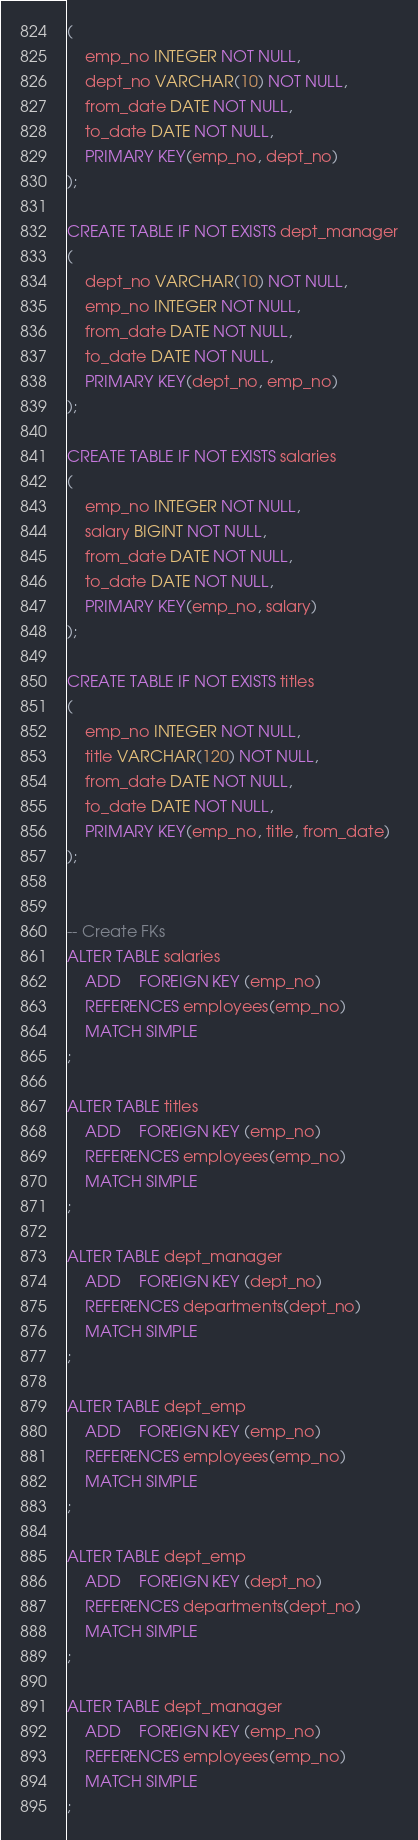Convert code to text. <code><loc_0><loc_0><loc_500><loc_500><_SQL_>(
    emp_no INTEGER NOT NULL,
    dept_no VARCHAR(10) NOT NULL,
    from_date DATE NOT NULL,
    to_date DATE NOT NULL,
    PRIMARY KEY(emp_no, dept_no)
);

CREATE TABLE IF NOT EXISTS dept_manager
(
    dept_no VARCHAR(10) NOT NULL,
    emp_no INTEGER NOT NULL,
    from_date DATE NOT NULL,
    to_date DATE NOT NULL,
    PRIMARY KEY(dept_no, emp_no)
);

CREATE TABLE IF NOT EXISTS salaries
(
    emp_no INTEGER NOT NULL,
    salary BIGINT NOT NULL,
    from_date DATE NOT NULL,
    to_date DATE NOT NULL,
    PRIMARY KEY(emp_no, salary)
);

CREATE TABLE IF NOT EXISTS titles
(
    emp_no INTEGER NOT NULL,
    title VARCHAR(120) NOT NULL,
    from_date DATE NOT NULL,
    to_date DATE NOT NULL,
    PRIMARY KEY(emp_no, title, from_date)
);


-- Create FKs
ALTER TABLE salaries
    ADD    FOREIGN KEY (emp_no)
    REFERENCES employees(emp_no)
    MATCH SIMPLE
;
    
ALTER TABLE titles
    ADD    FOREIGN KEY (emp_no)
    REFERENCES employees(emp_no)
    MATCH SIMPLE
;
    
ALTER TABLE dept_manager
    ADD    FOREIGN KEY (dept_no)
    REFERENCES departments(dept_no)
    MATCH SIMPLE
;
    
ALTER TABLE dept_emp
    ADD    FOREIGN KEY (emp_no)
    REFERENCES employees(emp_no)
    MATCH SIMPLE
;
    
ALTER TABLE dept_emp
    ADD    FOREIGN KEY (dept_no)
    REFERENCES departments(dept_no)
    MATCH SIMPLE
;
    
ALTER TABLE dept_manager
    ADD    FOREIGN KEY (emp_no)
    REFERENCES employees(emp_no)
    MATCH SIMPLE
;</code> 